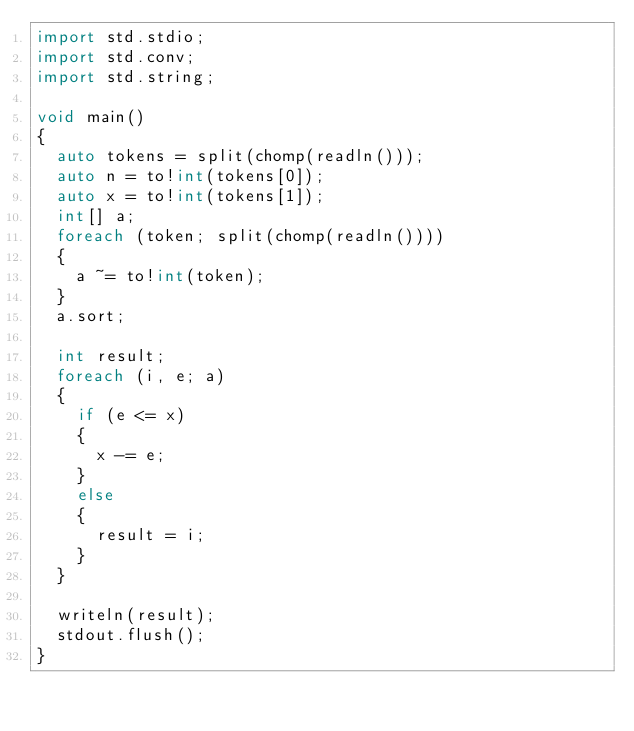<code> <loc_0><loc_0><loc_500><loc_500><_D_>import std.stdio;
import std.conv;
import std.string;

void main()
{
	auto tokens = split(chomp(readln()));
	auto n = to!int(tokens[0]);
	auto x = to!int(tokens[1]);
	int[] a;
	foreach (token; split(chomp(readln())))
	{
		a ~= to!int(token);
	}
	a.sort;
	
	int result;
	foreach (i, e; a)
	{
		if (e <= x)
		{
			x -= e;
		}
		else
		{
			result = i;
		}
	}

	writeln(result);
	stdout.flush();
}</code> 